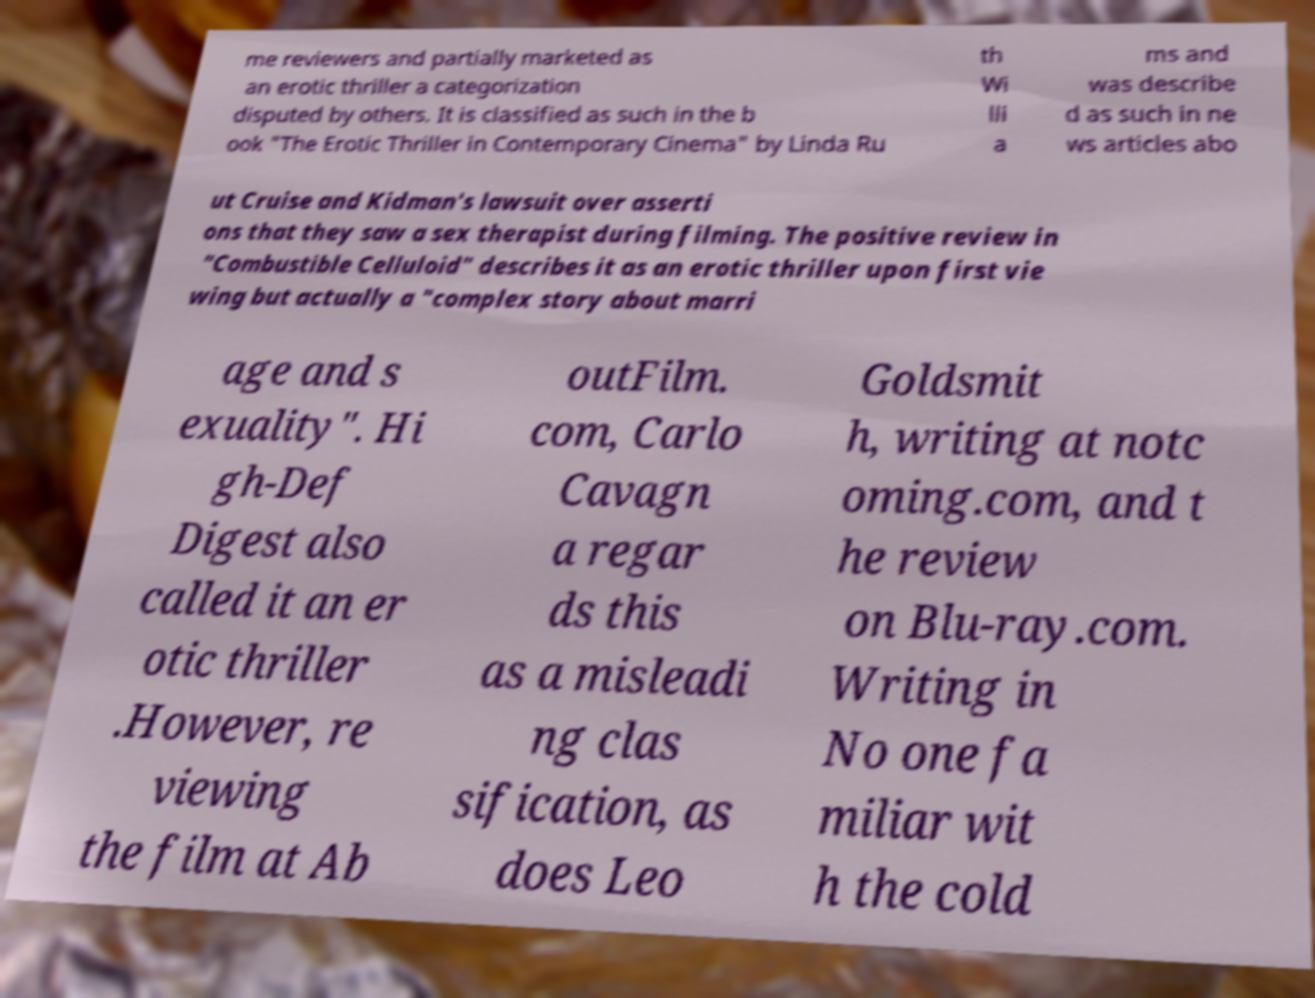What messages or text are displayed in this image? I need them in a readable, typed format. me reviewers and partially marketed as an erotic thriller a categorization disputed by others. It is classified as such in the b ook "The Erotic Thriller in Contemporary Cinema" by Linda Ru th Wi lli a ms and was describe d as such in ne ws articles abo ut Cruise and Kidman's lawsuit over asserti ons that they saw a sex therapist during filming. The positive review in "Combustible Celluloid" describes it as an erotic thriller upon first vie wing but actually a "complex story about marri age and s exuality". Hi gh-Def Digest also called it an er otic thriller .However, re viewing the film at Ab outFilm. com, Carlo Cavagn a regar ds this as a misleadi ng clas sification, as does Leo Goldsmit h, writing at notc oming.com, and t he review on Blu-ray.com. Writing in No one fa miliar wit h the cold 